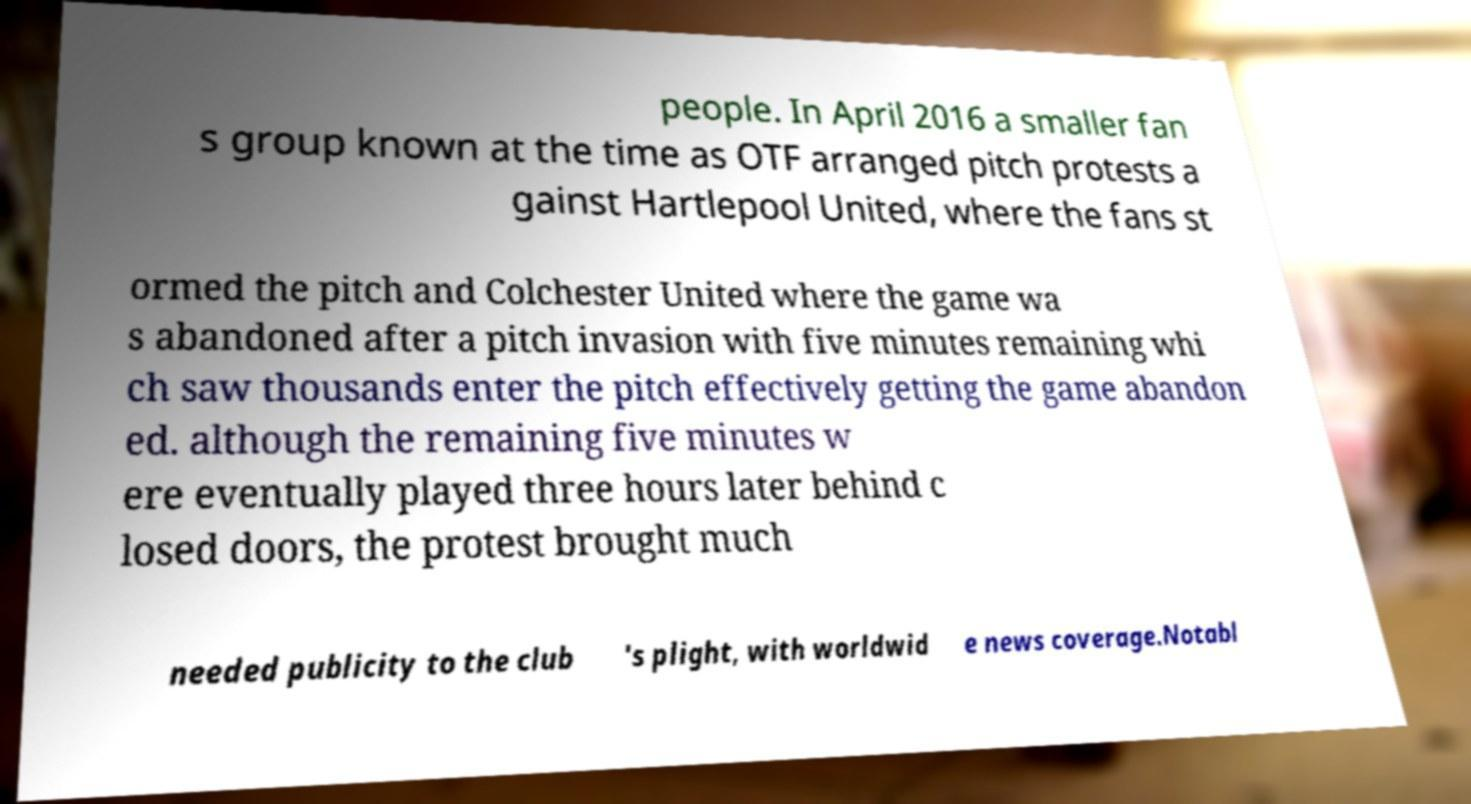Could you assist in decoding the text presented in this image and type it out clearly? people. In April 2016 a smaller fan s group known at the time as OTF arranged pitch protests a gainst Hartlepool United, where the fans st ormed the pitch and Colchester United where the game wa s abandoned after a pitch invasion with five minutes remaining whi ch saw thousands enter the pitch effectively getting the game abandon ed. although the remaining five minutes w ere eventually played three hours later behind c losed doors, the protest brought much needed publicity to the club 's plight, with worldwid e news coverage.Notabl 